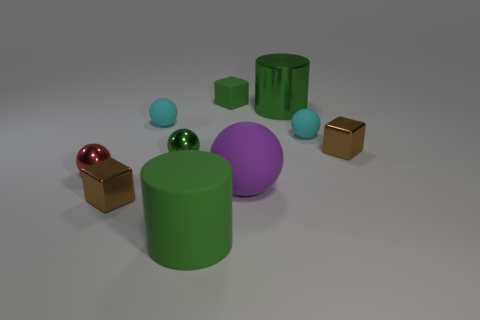Is the number of tiny metallic cubes less than the number of green matte cylinders?
Your response must be concise. No. The cube to the left of the cyan object on the left side of the purple ball is what color?
Make the answer very short. Brown. What material is the large cylinder that is on the left side of the shiny thing behind the metal block that is on the right side of the large green rubber cylinder?
Keep it short and to the point. Rubber. There is a brown object in front of the purple sphere; is its size the same as the rubber block?
Your response must be concise. Yes. What is the material of the cyan ball to the right of the big green metal thing?
Your answer should be very brief. Rubber. Are there more large purple matte things than metal cubes?
Your answer should be very brief. No. How many objects are either large cylinders behind the red metallic ball or small balls?
Offer a very short reply. 5. What number of large green rubber things are in front of the cube behind the green metal cylinder?
Make the answer very short. 1. There is a brown metal cube behind the small metal object that is on the left side of the block that is in front of the tiny red shiny ball; what is its size?
Your response must be concise. Small. There is a small rubber object to the left of the green metallic sphere; is it the same color as the small matte block?
Give a very brief answer. No. 